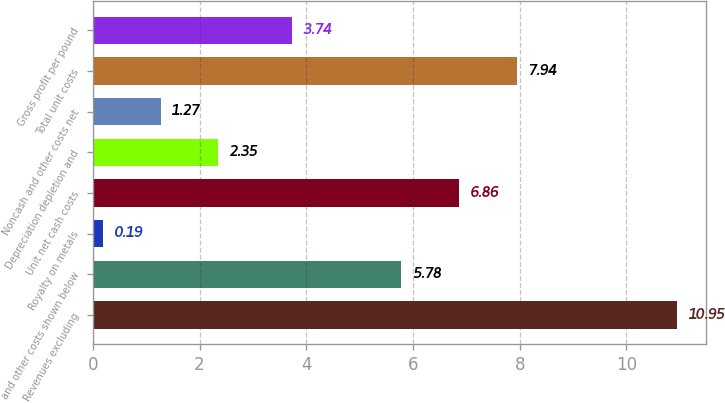Convert chart to OTSL. <chart><loc_0><loc_0><loc_500><loc_500><bar_chart><fcel>Revenues excluding<fcel>and other costs shown below<fcel>Royalty on metals<fcel>Unit net cash costs<fcel>Depreciation depletion and<fcel>Noncash and other costs net<fcel>Total unit costs<fcel>Gross profit per pound<nl><fcel>10.95<fcel>5.78<fcel>0.19<fcel>6.86<fcel>2.35<fcel>1.27<fcel>7.94<fcel>3.74<nl></chart> 